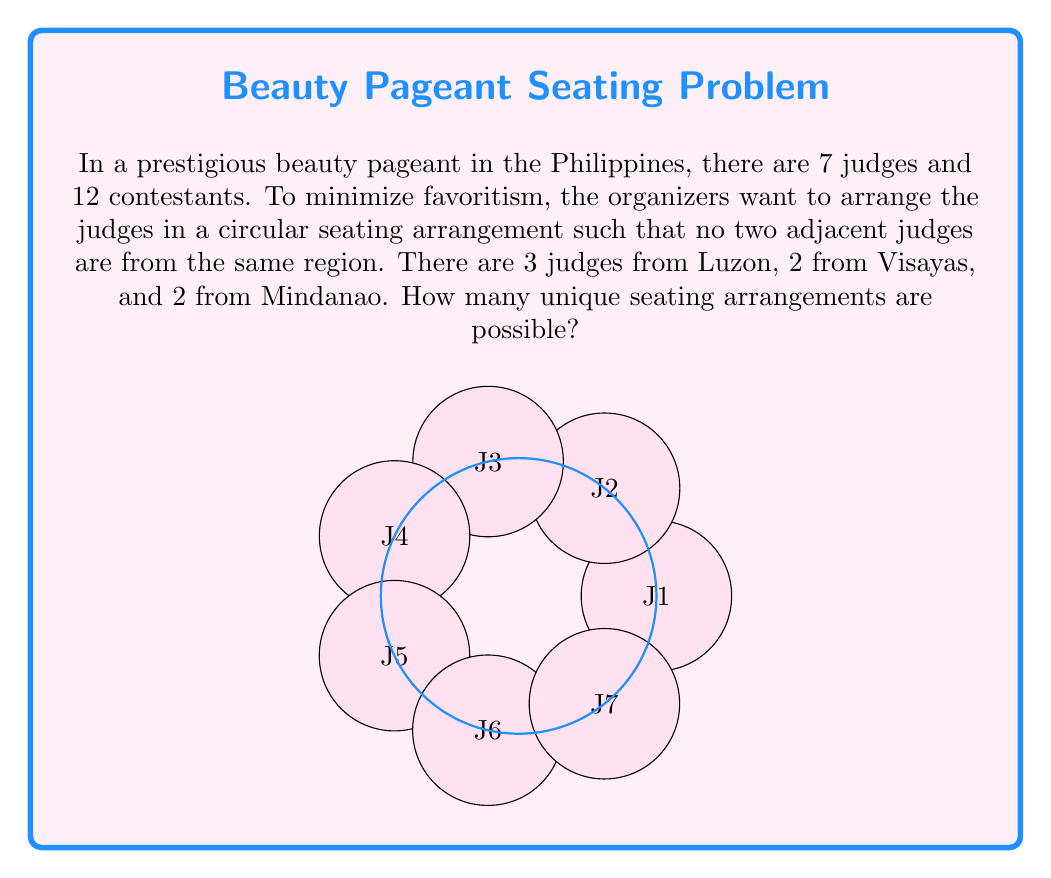Solve this math problem. Let's approach this step-by-step:

1) First, we need to understand that this is a circular permutation problem with additional constraints.

2) In a standard circular permutation, we would have $(n-1)!$ arrangements for $n$ judges. However, our constraints make this more complex.

3) Let's denote Luzon judges as L, Visayas as V, and Mindanao as M.

4) We can start by fixing one judge's position (let's say an L judge) to reduce the problem to a linear arrangement of 6 judges.

5) Now, we need to arrange LLVVMM in a line such that no two similar letters are adjacent.

6) One way to approach this is to first place the remaining two L judges, leaving gaps between them:

   L _ L _ L _

7) Now, we need to fill these gaps with V and M judges. We have 3 gaps and 4 judges (2V and 2M) to fill them.

8) We can choose which gap will have 2 judges in $\binom{3}{1} = 3$ ways.

9) For each of these 3 choices, we can arrange VV and MM in $2! = 2$ ways.

10) Finally, for each of these arrangements, we can permute the 2 V judges among themselves and the 2 M judges among themselves, giving us $2! \cdot 2! = 4$ possibilities for each arrangement.

11) Therefore, the total number of arrangements is:

    $3 \cdot 2 \cdot 4 = 24$

12) However, remember that we fixed one L judge at the start. We actually have 3 choices for which L judge to fix first.

13) Thus, our final answer is:

    $24 \cdot 3 = 72$
Answer: 72 